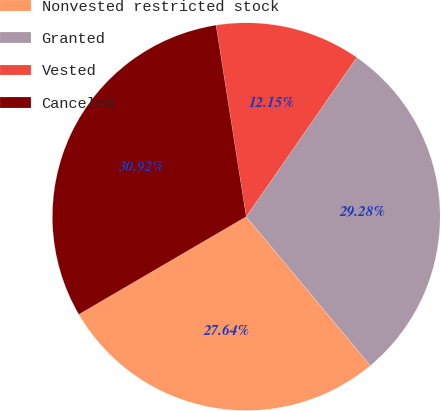Convert chart to OTSL. <chart><loc_0><loc_0><loc_500><loc_500><pie_chart><fcel>Nonvested restricted stock<fcel>Granted<fcel>Vested<fcel>Canceled<nl><fcel>27.64%<fcel>29.28%<fcel>12.15%<fcel>30.92%<nl></chart> 